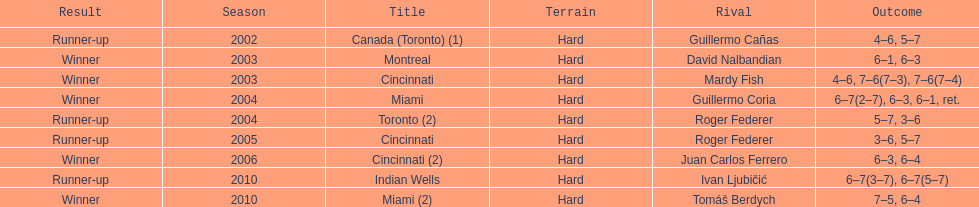How many times was roger federer a runner-up? 2. 